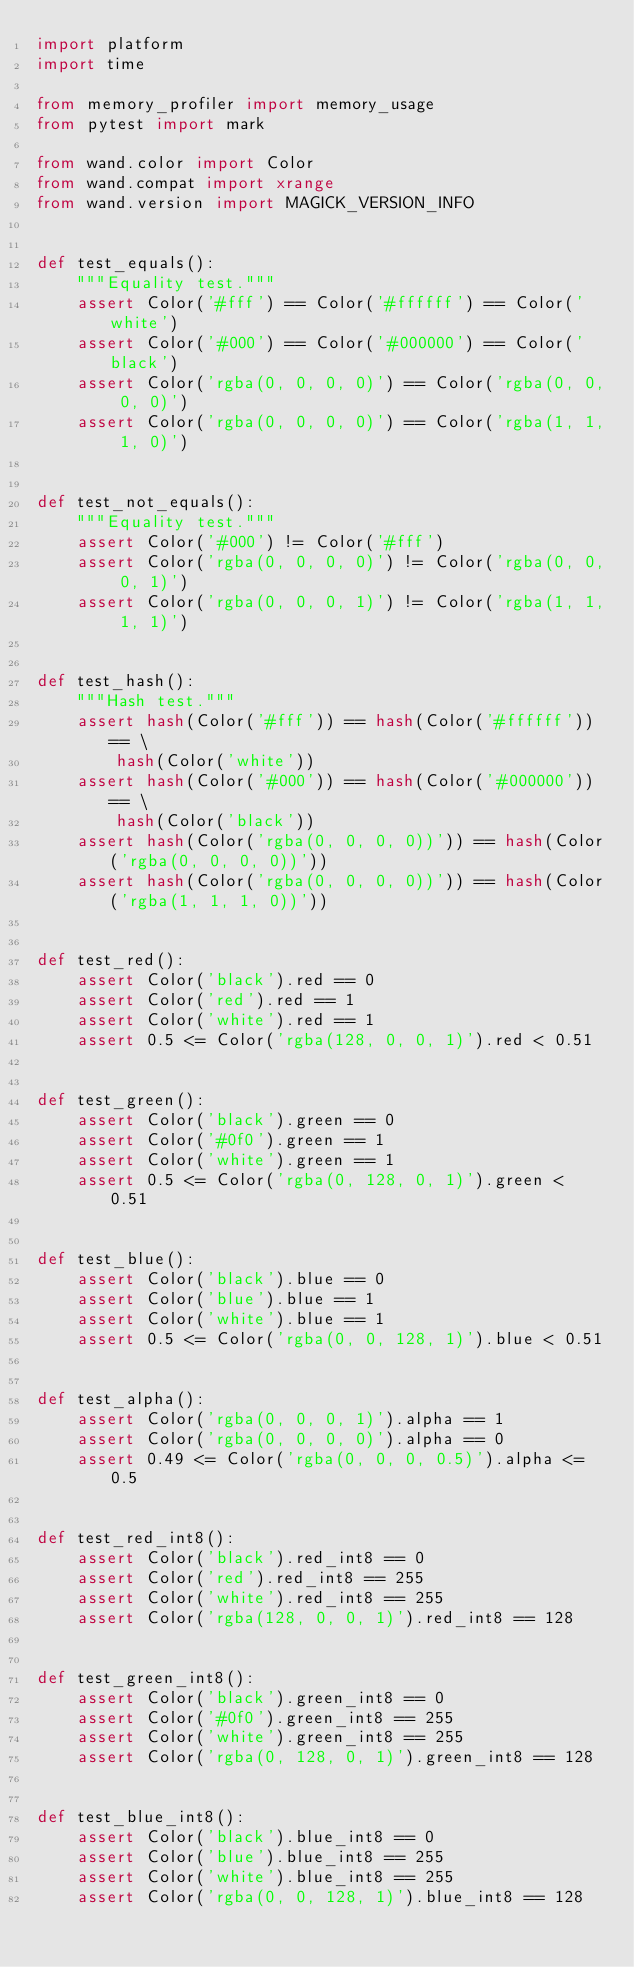<code> <loc_0><loc_0><loc_500><loc_500><_Python_>import platform
import time

from memory_profiler import memory_usage
from pytest import mark

from wand.color import Color
from wand.compat import xrange
from wand.version import MAGICK_VERSION_INFO


def test_equals():
    """Equality test."""
    assert Color('#fff') == Color('#ffffff') == Color('white')
    assert Color('#000') == Color('#000000') == Color('black')
    assert Color('rgba(0, 0, 0, 0)') == Color('rgba(0, 0, 0, 0)')
    assert Color('rgba(0, 0, 0, 0)') == Color('rgba(1, 1, 1, 0)')


def test_not_equals():
    """Equality test."""
    assert Color('#000') != Color('#fff')
    assert Color('rgba(0, 0, 0, 0)') != Color('rgba(0, 0, 0, 1)')
    assert Color('rgba(0, 0, 0, 1)') != Color('rgba(1, 1, 1, 1)')


def test_hash():
    """Hash test."""
    assert hash(Color('#fff')) == hash(Color('#ffffff')) == \
        hash(Color('white'))
    assert hash(Color('#000')) == hash(Color('#000000')) == \
        hash(Color('black'))
    assert hash(Color('rgba(0, 0, 0, 0))')) == hash(Color('rgba(0, 0, 0, 0))'))
    assert hash(Color('rgba(0, 0, 0, 0))')) == hash(Color('rgba(1, 1, 1, 0))'))


def test_red():
    assert Color('black').red == 0
    assert Color('red').red == 1
    assert Color('white').red == 1
    assert 0.5 <= Color('rgba(128, 0, 0, 1)').red < 0.51


def test_green():
    assert Color('black').green == 0
    assert Color('#0f0').green == 1
    assert Color('white').green == 1
    assert 0.5 <= Color('rgba(0, 128, 0, 1)').green < 0.51


def test_blue():
    assert Color('black').blue == 0
    assert Color('blue').blue == 1
    assert Color('white').blue == 1
    assert 0.5 <= Color('rgba(0, 0, 128, 1)').blue < 0.51


def test_alpha():
    assert Color('rgba(0, 0, 0, 1)').alpha == 1
    assert Color('rgba(0, 0, 0, 0)').alpha == 0
    assert 0.49 <= Color('rgba(0, 0, 0, 0.5)').alpha <= 0.5


def test_red_int8():
    assert Color('black').red_int8 == 0
    assert Color('red').red_int8 == 255
    assert Color('white').red_int8 == 255
    assert Color('rgba(128, 0, 0, 1)').red_int8 == 128


def test_green_int8():
    assert Color('black').green_int8 == 0
    assert Color('#0f0').green_int8 == 255
    assert Color('white').green_int8 == 255
    assert Color('rgba(0, 128, 0, 1)').green_int8 == 128


def test_blue_int8():
    assert Color('black').blue_int8 == 0
    assert Color('blue').blue_int8 == 255
    assert Color('white').blue_int8 == 255
    assert Color('rgba(0, 0, 128, 1)').blue_int8 == 128

</code> 